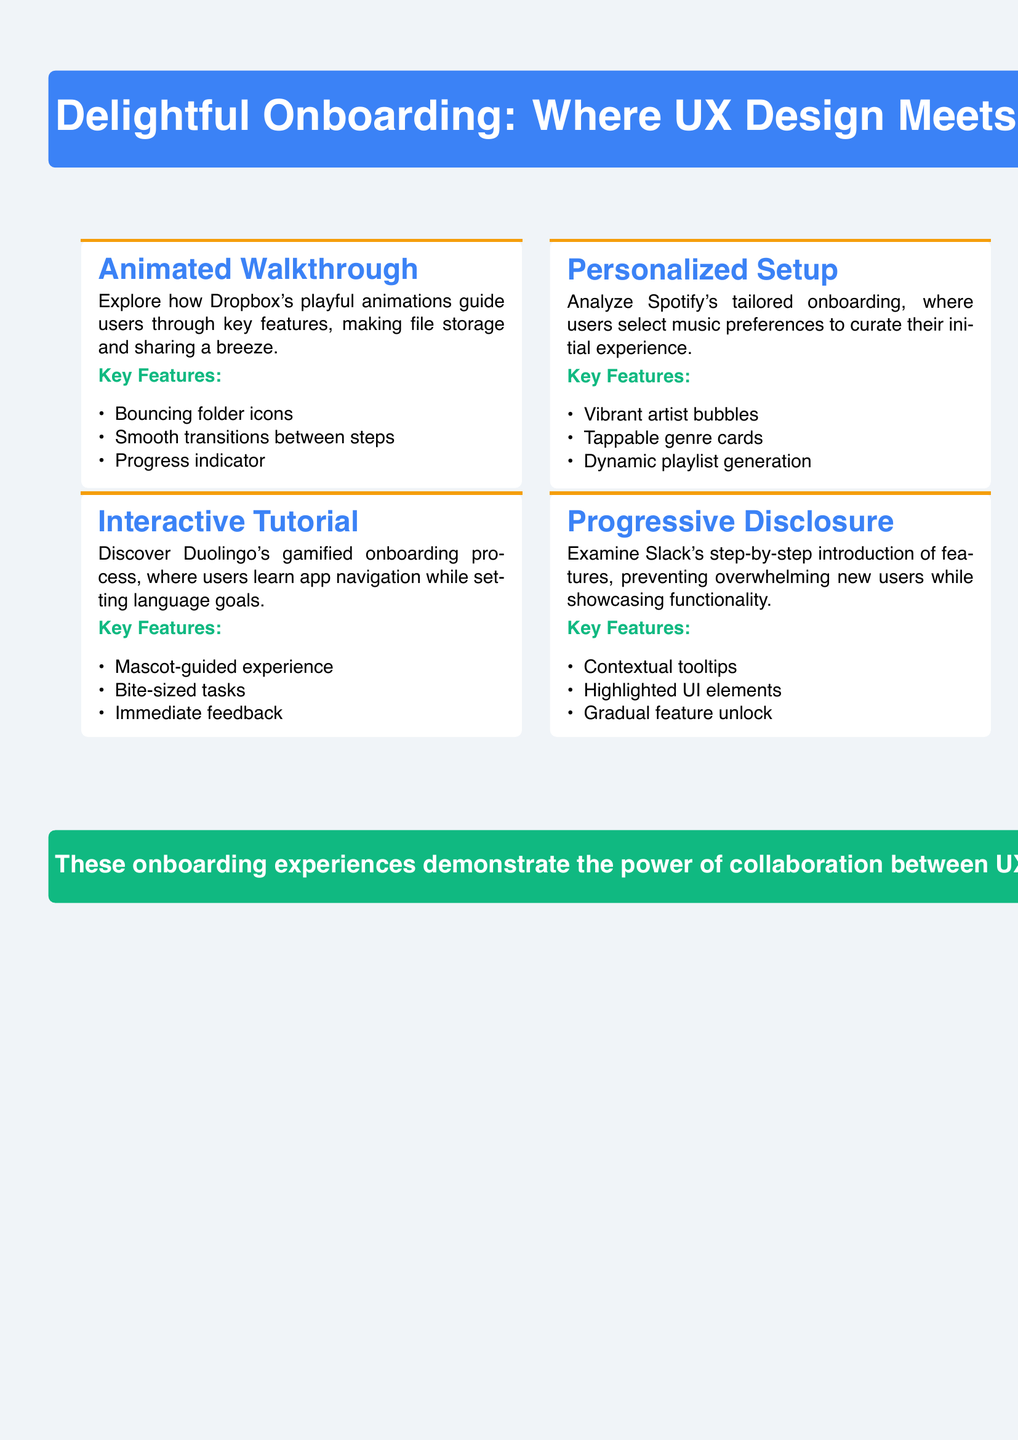What is the title of the document? The title is prominently displayed at the top of the document and highlights the focus on UX design and illustration in onboarding.
Answer: Delightful Onboarding: Where UX Design Meets Illustration How many onboarding experiences are highlighted? The document showcases a total of four distinct onboarding experiences.
Answer: 4 Which app uses animated walkthroughs? The document states that Dropbox utilizes playful animations for guiding users.
Answer: Dropbox What type of onboarding experience does Spotify offer? It is described that Spotify provides personalized onboarding based on user music preferences.
Answer: Personalized Setup Which onboarding method features a mascot-guided experience? The document specifies that Duolingo employs a mascot to assist users during onboarding.
Answer: Interactive Tutorial What is a key feature of the animated walkthrough from Dropbox? The document lists several features of Dropbox's onboarding, specifically mentioning a key function.
Answer: Bouncing folder icons Which app's onboarding process includes contextual tooltips? The relevant onboarding method featuring contextual tooltips is associated with Slack.
Answer: Slack What does the conclusion emphasize about the onboarding experiences? The conclusion highlights the collaborative effort behind creating visually appealing onboarding processes.
Answer: Collaboration between UX designers and illustrators 